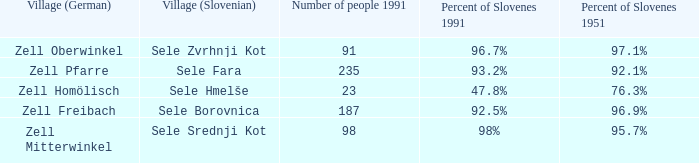Give me the minimum number of people in 1991 with 92.5% of Slovenes in 1991. 187.0. 